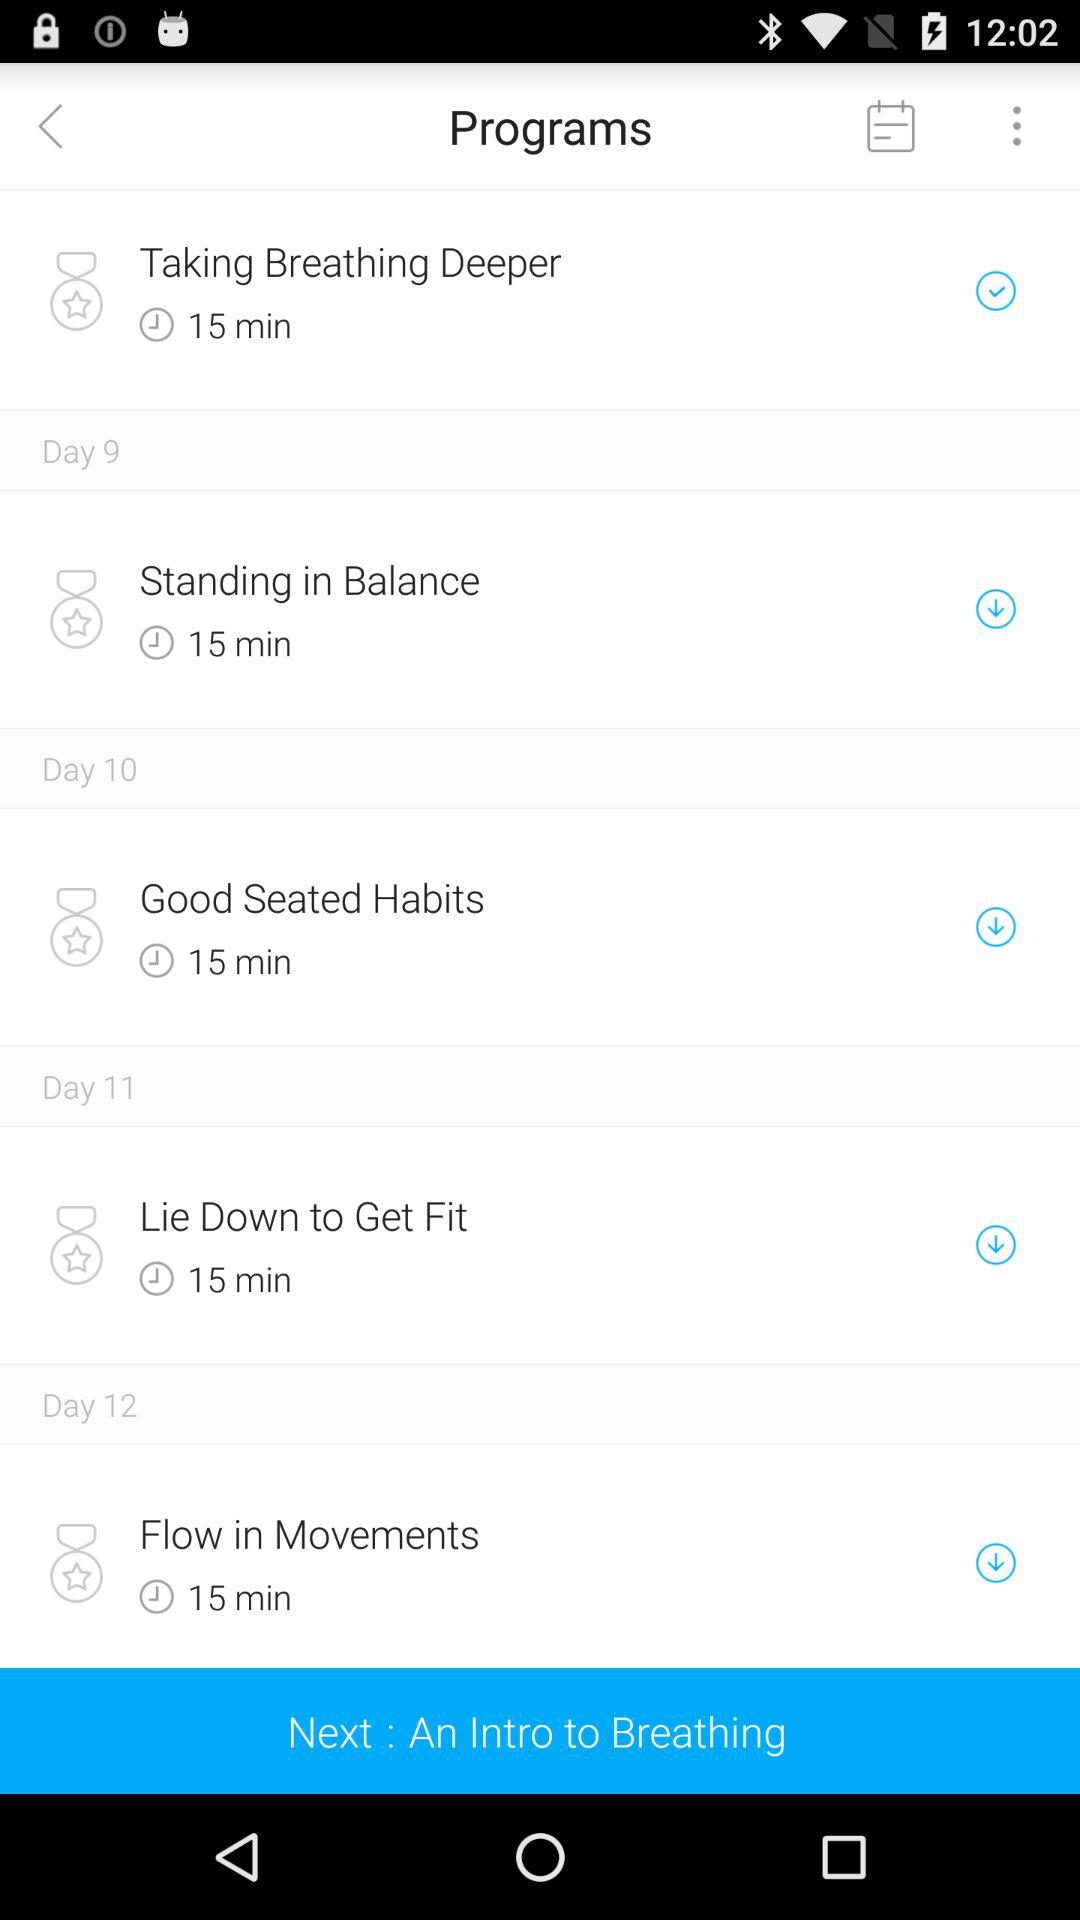What is the time duration of the program "Good Seated Habits"? The time duration of the program is 15 minutes. 